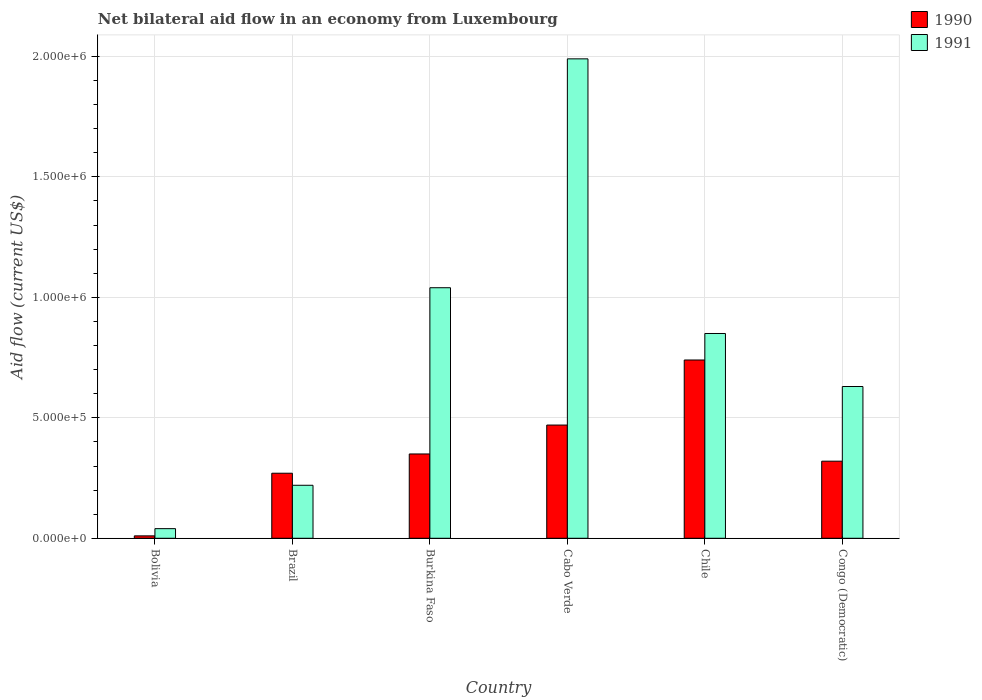How many different coloured bars are there?
Your answer should be very brief. 2. How many groups of bars are there?
Keep it short and to the point. 6. Are the number of bars on each tick of the X-axis equal?
Keep it short and to the point. Yes. What is the label of the 4th group of bars from the left?
Provide a succinct answer. Cabo Verde. What is the net bilateral aid flow in 1990 in Congo (Democratic)?
Ensure brevity in your answer.  3.20e+05. Across all countries, what is the maximum net bilateral aid flow in 1990?
Keep it short and to the point. 7.40e+05. In which country was the net bilateral aid flow in 1990 maximum?
Offer a very short reply. Chile. What is the total net bilateral aid flow in 1991 in the graph?
Make the answer very short. 4.77e+06. What is the difference between the net bilateral aid flow in 1991 in Brazil and that in Cabo Verde?
Give a very brief answer. -1.77e+06. What is the difference between the net bilateral aid flow in 1991 in Chile and the net bilateral aid flow in 1990 in Congo (Democratic)?
Offer a terse response. 5.30e+05. What is the average net bilateral aid flow in 1991 per country?
Your response must be concise. 7.95e+05. What is the difference between the net bilateral aid flow of/in 1991 and net bilateral aid flow of/in 1990 in Brazil?
Provide a succinct answer. -5.00e+04. What is the ratio of the net bilateral aid flow in 1991 in Burkina Faso to that in Congo (Democratic)?
Offer a terse response. 1.65. Is the net bilateral aid flow in 1991 in Brazil less than that in Congo (Democratic)?
Provide a short and direct response. Yes. Is the difference between the net bilateral aid flow in 1991 in Bolivia and Burkina Faso greater than the difference between the net bilateral aid flow in 1990 in Bolivia and Burkina Faso?
Offer a very short reply. No. What is the difference between the highest and the second highest net bilateral aid flow in 1991?
Your response must be concise. 1.14e+06. What is the difference between the highest and the lowest net bilateral aid flow in 1990?
Ensure brevity in your answer.  7.30e+05. Is the sum of the net bilateral aid flow in 1990 in Chile and Congo (Democratic) greater than the maximum net bilateral aid flow in 1991 across all countries?
Make the answer very short. No. How many countries are there in the graph?
Provide a short and direct response. 6. What is the difference between two consecutive major ticks on the Y-axis?
Offer a terse response. 5.00e+05. Are the values on the major ticks of Y-axis written in scientific E-notation?
Make the answer very short. Yes. Does the graph contain any zero values?
Provide a succinct answer. No. Where does the legend appear in the graph?
Give a very brief answer. Top right. How many legend labels are there?
Keep it short and to the point. 2. What is the title of the graph?
Provide a short and direct response. Net bilateral aid flow in an economy from Luxembourg. Does "2005" appear as one of the legend labels in the graph?
Offer a terse response. No. What is the label or title of the X-axis?
Your response must be concise. Country. What is the Aid flow (current US$) of 1990 in Bolivia?
Offer a terse response. 10000. What is the Aid flow (current US$) in 1991 in Brazil?
Make the answer very short. 2.20e+05. What is the Aid flow (current US$) of 1990 in Burkina Faso?
Your response must be concise. 3.50e+05. What is the Aid flow (current US$) in 1991 in Burkina Faso?
Give a very brief answer. 1.04e+06. What is the Aid flow (current US$) in 1991 in Cabo Verde?
Give a very brief answer. 1.99e+06. What is the Aid flow (current US$) in 1990 in Chile?
Your answer should be very brief. 7.40e+05. What is the Aid flow (current US$) of 1991 in Chile?
Your response must be concise. 8.50e+05. What is the Aid flow (current US$) in 1990 in Congo (Democratic)?
Provide a succinct answer. 3.20e+05. What is the Aid flow (current US$) of 1991 in Congo (Democratic)?
Give a very brief answer. 6.30e+05. Across all countries, what is the maximum Aid flow (current US$) in 1990?
Ensure brevity in your answer.  7.40e+05. Across all countries, what is the maximum Aid flow (current US$) in 1991?
Your response must be concise. 1.99e+06. Across all countries, what is the minimum Aid flow (current US$) in 1990?
Ensure brevity in your answer.  10000. Across all countries, what is the minimum Aid flow (current US$) of 1991?
Your response must be concise. 4.00e+04. What is the total Aid flow (current US$) in 1990 in the graph?
Give a very brief answer. 2.16e+06. What is the total Aid flow (current US$) in 1991 in the graph?
Ensure brevity in your answer.  4.77e+06. What is the difference between the Aid flow (current US$) in 1990 in Bolivia and that in Brazil?
Your response must be concise. -2.60e+05. What is the difference between the Aid flow (current US$) of 1991 in Bolivia and that in Brazil?
Provide a succinct answer. -1.80e+05. What is the difference between the Aid flow (current US$) in 1990 in Bolivia and that in Burkina Faso?
Provide a succinct answer. -3.40e+05. What is the difference between the Aid flow (current US$) of 1991 in Bolivia and that in Burkina Faso?
Give a very brief answer. -1.00e+06. What is the difference between the Aid flow (current US$) of 1990 in Bolivia and that in Cabo Verde?
Offer a terse response. -4.60e+05. What is the difference between the Aid flow (current US$) in 1991 in Bolivia and that in Cabo Verde?
Offer a very short reply. -1.95e+06. What is the difference between the Aid flow (current US$) of 1990 in Bolivia and that in Chile?
Make the answer very short. -7.30e+05. What is the difference between the Aid flow (current US$) of 1991 in Bolivia and that in Chile?
Your answer should be compact. -8.10e+05. What is the difference between the Aid flow (current US$) of 1990 in Bolivia and that in Congo (Democratic)?
Give a very brief answer. -3.10e+05. What is the difference between the Aid flow (current US$) of 1991 in Bolivia and that in Congo (Democratic)?
Ensure brevity in your answer.  -5.90e+05. What is the difference between the Aid flow (current US$) in 1990 in Brazil and that in Burkina Faso?
Give a very brief answer. -8.00e+04. What is the difference between the Aid flow (current US$) of 1991 in Brazil and that in Burkina Faso?
Offer a very short reply. -8.20e+05. What is the difference between the Aid flow (current US$) in 1990 in Brazil and that in Cabo Verde?
Provide a short and direct response. -2.00e+05. What is the difference between the Aid flow (current US$) of 1991 in Brazil and that in Cabo Verde?
Keep it short and to the point. -1.77e+06. What is the difference between the Aid flow (current US$) in 1990 in Brazil and that in Chile?
Provide a succinct answer. -4.70e+05. What is the difference between the Aid flow (current US$) of 1991 in Brazil and that in Chile?
Give a very brief answer. -6.30e+05. What is the difference between the Aid flow (current US$) of 1991 in Brazil and that in Congo (Democratic)?
Offer a very short reply. -4.10e+05. What is the difference between the Aid flow (current US$) of 1991 in Burkina Faso and that in Cabo Verde?
Your answer should be compact. -9.50e+05. What is the difference between the Aid flow (current US$) of 1990 in Burkina Faso and that in Chile?
Offer a terse response. -3.90e+05. What is the difference between the Aid flow (current US$) of 1990 in Burkina Faso and that in Congo (Democratic)?
Your response must be concise. 3.00e+04. What is the difference between the Aid flow (current US$) in 1990 in Cabo Verde and that in Chile?
Provide a short and direct response. -2.70e+05. What is the difference between the Aid flow (current US$) of 1991 in Cabo Verde and that in Chile?
Ensure brevity in your answer.  1.14e+06. What is the difference between the Aid flow (current US$) in 1990 in Cabo Verde and that in Congo (Democratic)?
Ensure brevity in your answer.  1.50e+05. What is the difference between the Aid flow (current US$) in 1991 in Cabo Verde and that in Congo (Democratic)?
Give a very brief answer. 1.36e+06. What is the difference between the Aid flow (current US$) of 1990 in Bolivia and the Aid flow (current US$) of 1991 in Burkina Faso?
Your response must be concise. -1.03e+06. What is the difference between the Aid flow (current US$) of 1990 in Bolivia and the Aid flow (current US$) of 1991 in Cabo Verde?
Your answer should be compact. -1.98e+06. What is the difference between the Aid flow (current US$) of 1990 in Bolivia and the Aid flow (current US$) of 1991 in Chile?
Keep it short and to the point. -8.40e+05. What is the difference between the Aid flow (current US$) of 1990 in Bolivia and the Aid flow (current US$) of 1991 in Congo (Democratic)?
Your answer should be compact. -6.20e+05. What is the difference between the Aid flow (current US$) in 1990 in Brazil and the Aid flow (current US$) in 1991 in Burkina Faso?
Ensure brevity in your answer.  -7.70e+05. What is the difference between the Aid flow (current US$) in 1990 in Brazil and the Aid flow (current US$) in 1991 in Cabo Verde?
Your answer should be compact. -1.72e+06. What is the difference between the Aid flow (current US$) in 1990 in Brazil and the Aid flow (current US$) in 1991 in Chile?
Give a very brief answer. -5.80e+05. What is the difference between the Aid flow (current US$) of 1990 in Brazil and the Aid flow (current US$) of 1991 in Congo (Democratic)?
Ensure brevity in your answer.  -3.60e+05. What is the difference between the Aid flow (current US$) in 1990 in Burkina Faso and the Aid flow (current US$) in 1991 in Cabo Verde?
Your answer should be very brief. -1.64e+06. What is the difference between the Aid flow (current US$) of 1990 in Burkina Faso and the Aid flow (current US$) of 1991 in Chile?
Ensure brevity in your answer.  -5.00e+05. What is the difference between the Aid flow (current US$) in 1990 in Burkina Faso and the Aid flow (current US$) in 1991 in Congo (Democratic)?
Offer a very short reply. -2.80e+05. What is the difference between the Aid flow (current US$) in 1990 in Cabo Verde and the Aid flow (current US$) in 1991 in Chile?
Ensure brevity in your answer.  -3.80e+05. What is the average Aid flow (current US$) in 1991 per country?
Your answer should be compact. 7.95e+05. What is the difference between the Aid flow (current US$) in 1990 and Aid flow (current US$) in 1991 in Brazil?
Ensure brevity in your answer.  5.00e+04. What is the difference between the Aid flow (current US$) of 1990 and Aid flow (current US$) of 1991 in Burkina Faso?
Offer a very short reply. -6.90e+05. What is the difference between the Aid flow (current US$) in 1990 and Aid flow (current US$) in 1991 in Cabo Verde?
Offer a very short reply. -1.52e+06. What is the difference between the Aid flow (current US$) of 1990 and Aid flow (current US$) of 1991 in Chile?
Give a very brief answer. -1.10e+05. What is the difference between the Aid flow (current US$) in 1990 and Aid flow (current US$) in 1991 in Congo (Democratic)?
Keep it short and to the point. -3.10e+05. What is the ratio of the Aid flow (current US$) of 1990 in Bolivia to that in Brazil?
Offer a very short reply. 0.04. What is the ratio of the Aid flow (current US$) in 1991 in Bolivia to that in Brazil?
Your response must be concise. 0.18. What is the ratio of the Aid flow (current US$) in 1990 in Bolivia to that in Burkina Faso?
Provide a short and direct response. 0.03. What is the ratio of the Aid flow (current US$) of 1991 in Bolivia to that in Burkina Faso?
Your answer should be compact. 0.04. What is the ratio of the Aid flow (current US$) of 1990 in Bolivia to that in Cabo Verde?
Provide a succinct answer. 0.02. What is the ratio of the Aid flow (current US$) in 1991 in Bolivia to that in Cabo Verde?
Make the answer very short. 0.02. What is the ratio of the Aid flow (current US$) in 1990 in Bolivia to that in Chile?
Ensure brevity in your answer.  0.01. What is the ratio of the Aid flow (current US$) of 1991 in Bolivia to that in Chile?
Ensure brevity in your answer.  0.05. What is the ratio of the Aid flow (current US$) of 1990 in Bolivia to that in Congo (Democratic)?
Your answer should be very brief. 0.03. What is the ratio of the Aid flow (current US$) in 1991 in Bolivia to that in Congo (Democratic)?
Your answer should be compact. 0.06. What is the ratio of the Aid flow (current US$) of 1990 in Brazil to that in Burkina Faso?
Make the answer very short. 0.77. What is the ratio of the Aid flow (current US$) of 1991 in Brazil to that in Burkina Faso?
Your answer should be very brief. 0.21. What is the ratio of the Aid flow (current US$) of 1990 in Brazil to that in Cabo Verde?
Provide a succinct answer. 0.57. What is the ratio of the Aid flow (current US$) in 1991 in Brazil to that in Cabo Verde?
Provide a succinct answer. 0.11. What is the ratio of the Aid flow (current US$) in 1990 in Brazil to that in Chile?
Offer a terse response. 0.36. What is the ratio of the Aid flow (current US$) in 1991 in Brazil to that in Chile?
Make the answer very short. 0.26. What is the ratio of the Aid flow (current US$) in 1990 in Brazil to that in Congo (Democratic)?
Give a very brief answer. 0.84. What is the ratio of the Aid flow (current US$) of 1991 in Brazil to that in Congo (Democratic)?
Your response must be concise. 0.35. What is the ratio of the Aid flow (current US$) of 1990 in Burkina Faso to that in Cabo Verde?
Keep it short and to the point. 0.74. What is the ratio of the Aid flow (current US$) in 1991 in Burkina Faso to that in Cabo Verde?
Your answer should be compact. 0.52. What is the ratio of the Aid flow (current US$) in 1990 in Burkina Faso to that in Chile?
Your answer should be compact. 0.47. What is the ratio of the Aid flow (current US$) of 1991 in Burkina Faso to that in Chile?
Ensure brevity in your answer.  1.22. What is the ratio of the Aid flow (current US$) of 1990 in Burkina Faso to that in Congo (Democratic)?
Your response must be concise. 1.09. What is the ratio of the Aid flow (current US$) in 1991 in Burkina Faso to that in Congo (Democratic)?
Offer a very short reply. 1.65. What is the ratio of the Aid flow (current US$) of 1990 in Cabo Verde to that in Chile?
Make the answer very short. 0.64. What is the ratio of the Aid flow (current US$) of 1991 in Cabo Verde to that in Chile?
Provide a short and direct response. 2.34. What is the ratio of the Aid flow (current US$) in 1990 in Cabo Verde to that in Congo (Democratic)?
Keep it short and to the point. 1.47. What is the ratio of the Aid flow (current US$) of 1991 in Cabo Verde to that in Congo (Democratic)?
Your answer should be compact. 3.16. What is the ratio of the Aid flow (current US$) in 1990 in Chile to that in Congo (Democratic)?
Make the answer very short. 2.31. What is the ratio of the Aid flow (current US$) in 1991 in Chile to that in Congo (Democratic)?
Keep it short and to the point. 1.35. What is the difference between the highest and the second highest Aid flow (current US$) of 1991?
Your answer should be compact. 9.50e+05. What is the difference between the highest and the lowest Aid flow (current US$) in 1990?
Your response must be concise. 7.30e+05. What is the difference between the highest and the lowest Aid flow (current US$) in 1991?
Your response must be concise. 1.95e+06. 